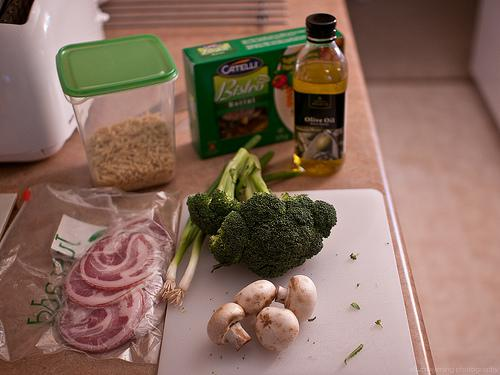Question: what color is the broccoli?
Choices:
A. Grey.
B. Black.
C. Green.
D. Brown.
Answer with the letter. Answer: C Question: where are the mushrooms located?
Choices:
A. On the kitchen counter.
B. Cutting board.
C. By the fridge.
D. By the oven.
Answer with the letter. Answer: B Question: how many mushrooms are there?
Choices:
A. Twelve.
B. Eight.
C. Four.
D. Seven.
Answer with the letter. Answer: C Question: where is the cutting board?
Choices:
A. In the kitchen.
B. By the sink.
C. By the fridge.
D. Counter.
Answer with the letter. Answer: D Question: what is in the bottle?
Choices:
A. Olive oil.
B. Vegetable oil.
C. Coconut milk.
D. Soy sauce.
Answer with the letter. Answer: A 